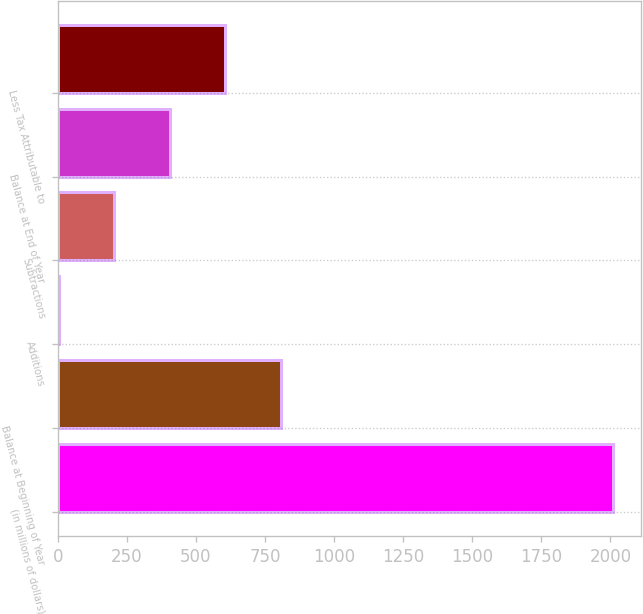<chart> <loc_0><loc_0><loc_500><loc_500><bar_chart><fcel>(in millions of dollars)<fcel>Balance at Beginning of Year<fcel>Additions<fcel>Subtractions<fcel>Balance at End of Year<fcel>Less Tax Attributable to<nl><fcel>2011<fcel>807.04<fcel>4.4<fcel>205.06<fcel>405.72<fcel>606.38<nl></chart> 